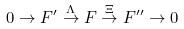<formula> <loc_0><loc_0><loc_500><loc_500>0 \rightarrow F ^ { \prime } \overset { \Lambda } { \rightarrow } F \overset { \Xi } { \rightarrow } F ^ { \prime \prime } \rightarrow 0</formula> 